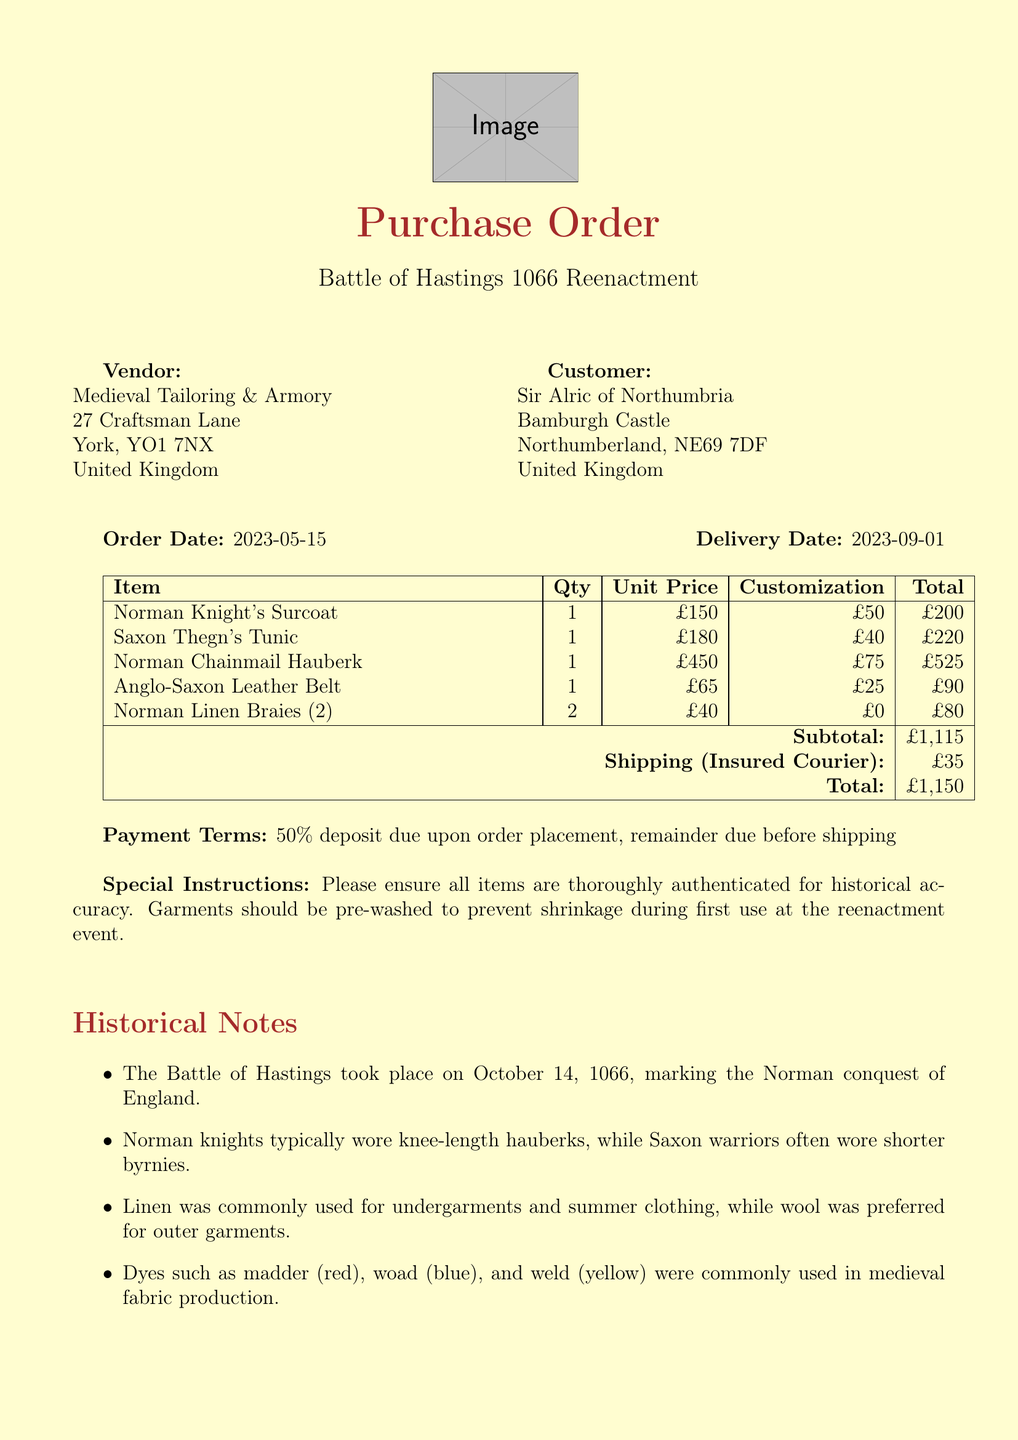What is the name of the event? The document lists the event as the "Battle of Hastings 1066 Reenactment."
Answer: Battle of Hastings 1066 Reenactment Who is the vendor? The vendor's name in the document is "Medieval Tailoring & Armory."
Answer: Medieval Tailoring & Armory What is the delivery date? The delivery date specified in the document is "2023-09-01."
Answer: 2023-09-01 How many Norman Chainmail Hauberks were ordered? The document states that the quantity ordered for the Norman Chainmail Hauberk is 1.
Answer: 1 What is the total cost including shipping? The total cost after adding the shipping cost to the subtotal of £1,115 is listed as £1,150.
Answer: £1,150 What customization was done on the Anglo-Saxon Leather Belt? The document notes that the customization for the belt is "Stamped with authentic 11th-century patterns."
Answer: Stamped with authentic 11th-century patterns What fabric is used for the Saxon Thegn's Tunic? The document indicates that the fabric for the Saxon Thegn's Tunic is "100% wool, medium weight."
Answer: 100% wool, medium weight What payment terms are outlined? The payment terms stated in the document express that a "50% deposit due upon order placement, remainder due before shipping."
Answer: 50% deposit due upon order placement, remainder due before shipping What special instructions were given for the garments? The document details that the special instructions are to ensure all items are "thoroughly authenticated for historical accuracy."
Answer: thoroughly authenticated for historical accuracy 